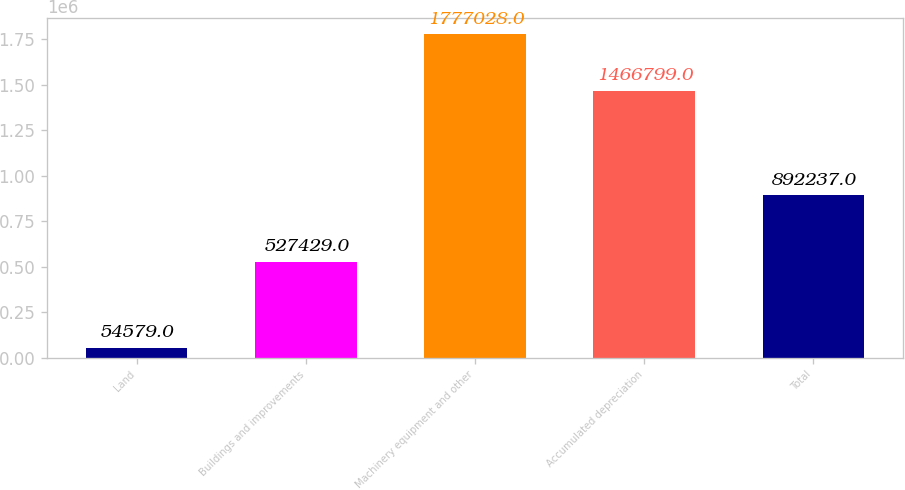Convert chart. <chart><loc_0><loc_0><loc_500><loc_500><bar_chart><fcel>Land<fcel>Buildings and improvements<fcel>Machinery equipment and other<fcel>Accumulated depreciation<fcel>Total<nl><fcel>54579<fcel>527429<fcel>1.77703e+06<fcel>1.4668e+06<fcel>892237<nl></chart> 